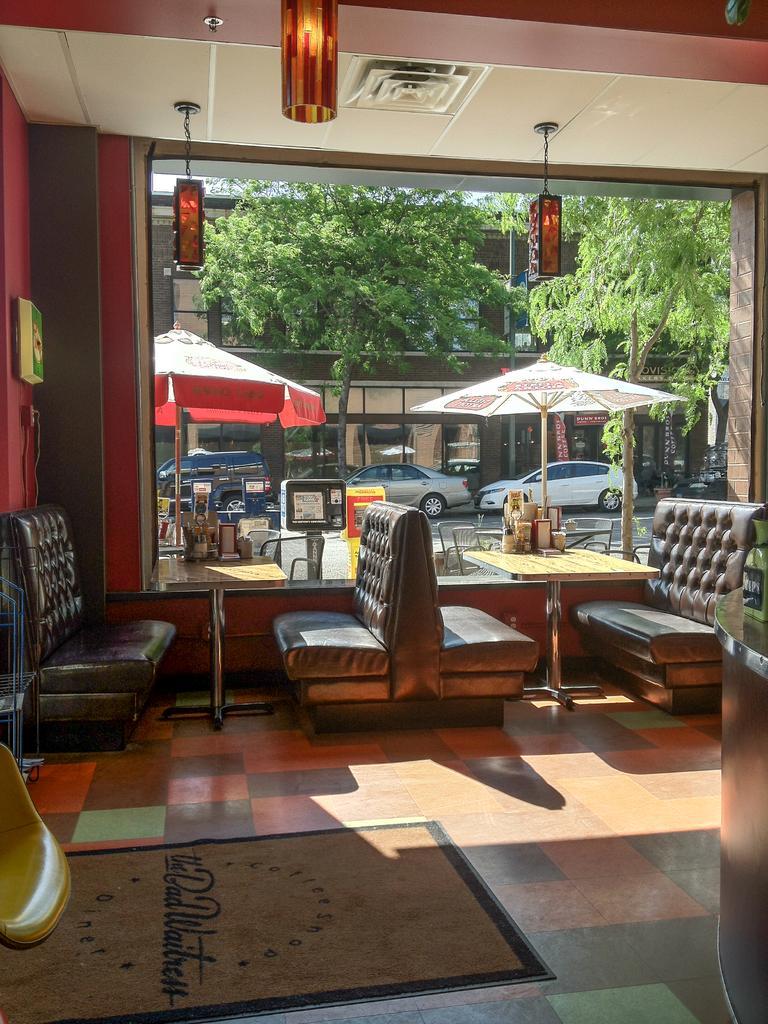Describe this image in one or two sentences. In the foreground of this image, there is a chair, mat on the floor, a bottle on the table. In the background, there are couches, tables on which few objects are placed, lights to the ceiling, wall on the left, a glass wall and we can also see through the glass, there are umbrellas, tables, chairs, cars on the road, trees and a building. 